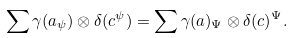Convert formula to latex. <formula><loc_0><loc_0><loc_500><loc_500>\sum \gamma ( a _ { \psi } ) \otimes \delta ( c ^ { \psi } ) = \sum \gamma ( a ) _ { \Psi } \otimes \delta ( c ) ^ { \Psi } .</formula> 